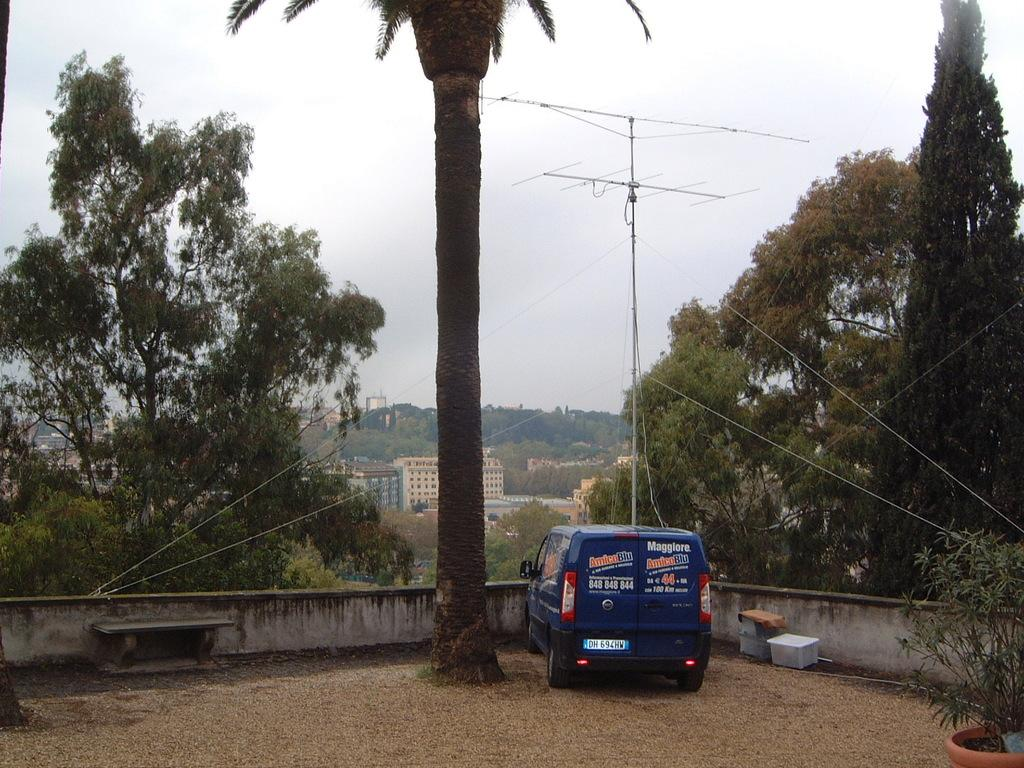What type of seating is visible in the image? There is a bench in the image. What objects are present that might be used for storage or organization? There are boxes in the image. What type of plant can be seen in the image? There is a plant in a pot in the image. What mode of transportation is present in the image? There is a vehicle in the image. What type of structure can be seen in the image? There is a wall in the image. What type of vegetation is visible in the image? There are trees in the image. What type of buildings can be seen in the image? There are buildings with windows in the image. What type of vertical structures are present in the image? There are poles in the image. What type of communication device is visible in the image? There is an antenna in the image. What part of the natural environment is visible in the image? The sky is visible in the image. What type of coal is being used to fuel the insect in the image? There is no coal or insect present in the image. How many pins are holding up the plant in the image? There are no pins present in the image; the plant is in a pot. 